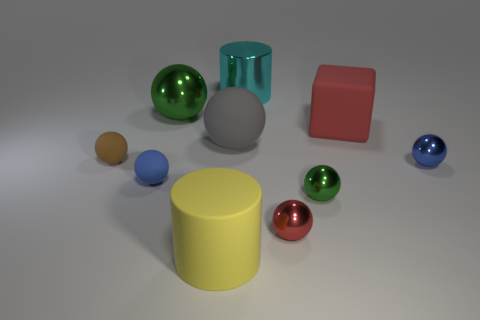What number of other things are there of the same size as the red metallic ball?
Your answer should be compact. 4. There is a tiny shiny thing on the right side of the green ball in front of the red thing behind the small green sphere; what color is it?
Your response must be concise. Blue. What shape is the metal object that is both to the right of the cyan metallic object and behind the tiny green shiny object?
Keep it short and to the point. Sphere. What number of other things are the same shape as the big yellow rubber thing?
Ensure brevity in your answer.  1. There is a red object right of the red object that is in front of the green ball that is in front of the big green object; what shape is it?
Provide a short and direct response. Cube. How many things are either small green shiny objects or tiny spheres that are in front of the brown matte thing?
Provide a succinct answer. 4. There is a green shiny object on the right side of the large yellow cylinder; does it have the same shape as the yellow object that is on the left side of the red matte block?
Offer a very short reply. No. What number of objects are either tiny purple rubber balls or red objects?
Provide a succinct answer. 2. Are any tiny brown rubber objects visible?
Keep it short and to the point. Yes. Is the small object left of the blue matte thing made of the same material as the red sphere?
Give a very brief answer. No. 